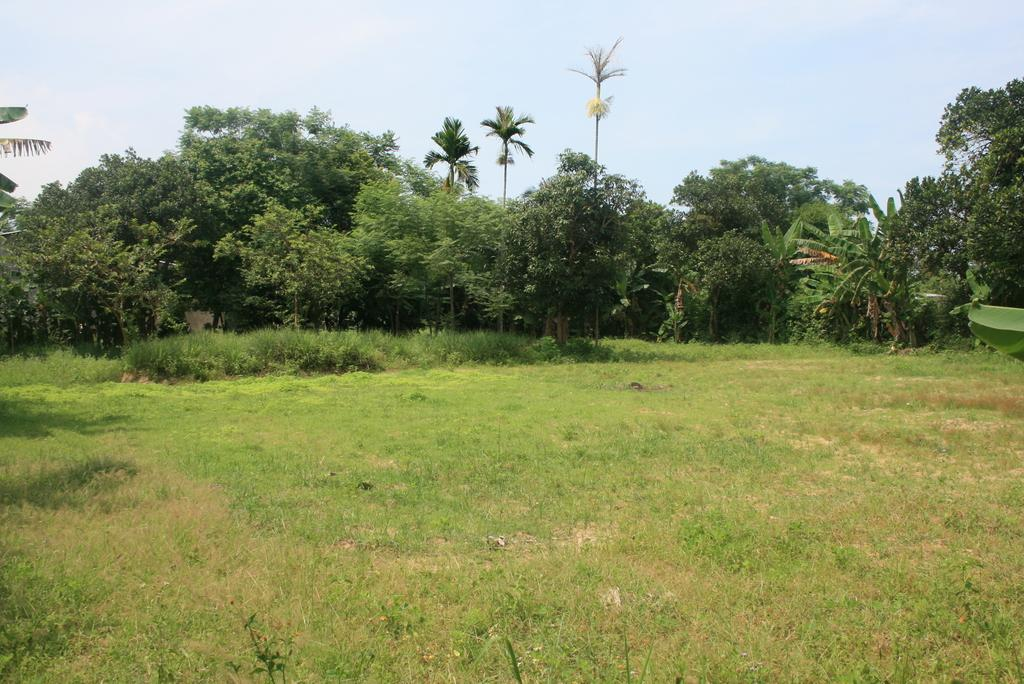What type of vegetation is at the bottom of the image? There is grass at the bottom of the image. What can be seen in the background of the image? There are trees and plants in the background of the image. What is visible at the top of the image? The sky is visible at the top of the image. Can you see any fangs on the trees in the image? There are no fangs present in the image; it features trees and plants in the background. How many frogs are sitting on the grass in the image? There are no frogs present in the image; it features grass at the bottom and trees and plants in the background. 